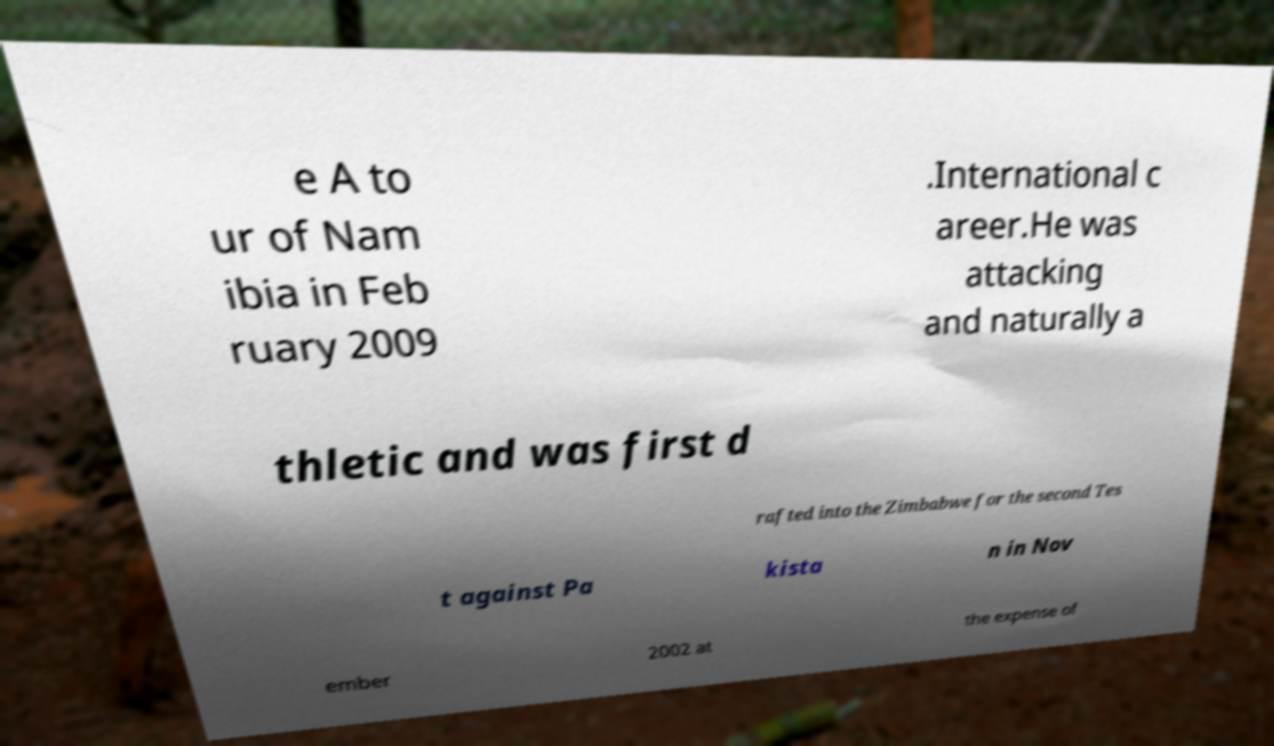There's text embedded in this image that I need extracted. Can you transcribe it verbatim? e A to ur of Nam ibia in Feb ruary 2009 .International c areer.He was attacking and naturally a thletic and was first d rafted into the Zimbabwe for the second Tes t against Pa kista n in Nov ember 2002 at the expense of 